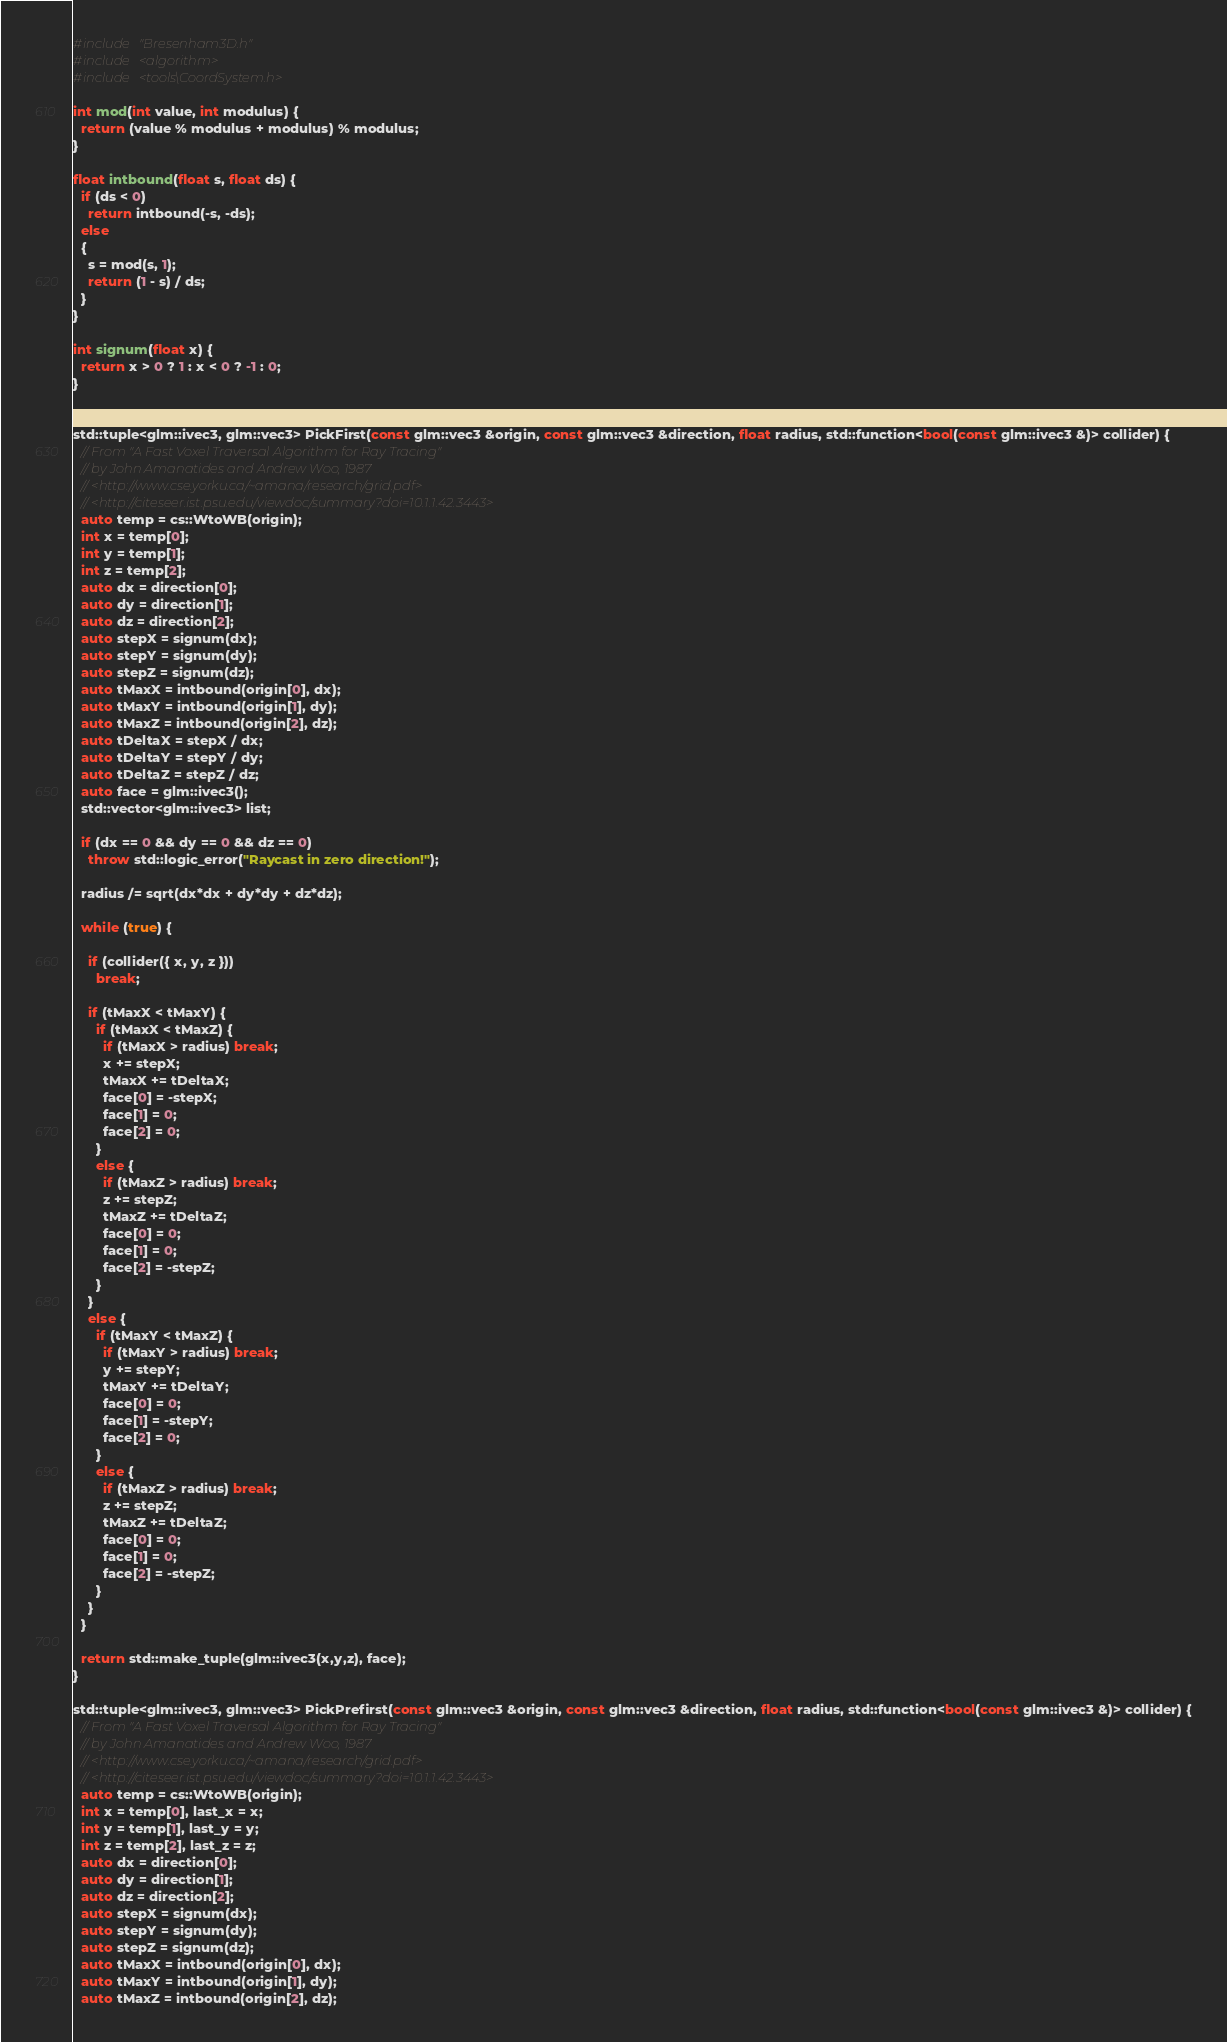<code> <loc_0><loc_0><loc_500><loc_500><_C++_>#include "Bresenham3D.h"
#include <algorithm>
#include <tools\CoordSystem.h>

int mod(int value, int modulus) {
  return (value % modulus + modulus) % modulus;
}

float intbound(float s, float ds) {
  if (ds < 0)
    return intbound(-s, -ds);
  else 
  {
    s = mod(s, 1);
    return (1 - s) / ds;
  }
}

int signum(float x) {
  return x > 0 ? 1 : x < 0 ? -1 : 0;
}


std::tuple<glm::ivec3, glm::vec3> PickFirst(const glm::vec3 &origin, const glm::vec3 &direction, float radius, std::function<bool(const glm::ivec3 &)> collider) {
  // From "A Fast Voxel Traversal Algorithm for Ray Tracing"
  // by John Amanatides and Andrew Woo, 1987
  // <http://www.cse.yorku.ca/~amana/research/grid.pdf>
  // <http://citeseer.ist.psu.edu/viewdoc/summary?doi=10.1.1.42.3443>
  auto temp = cs::WtoWB(origin);
  int x = temp[0];
  int y = temp[1];
  int z = temp[2];
  auto dx = direction[0];
  auto dy = direction[1];
  auto dz = direction[2];
  auto stepX = signum(dx);
  auto stepY = signum(dy);
  auto stepZ = signum(dz);
  auto tMaxX = intbound(origin[0], dx);
  auto tMaxY = intbound(origin[1], dy);
  auto tMaxZ = intbound(origin[2], dz);
  auto tDeltaX = stepX / dx;
  auto tDeltaY = stepY / dy;
  auto tDeltaZ = stepZ / dz;
  auto face = glm::ivec3();
  std::vector<glm::ivec3> list;

  if (dx == 0 && dy == 0 && dz == 0)
    throw std::logic_error("Raycast in zero direction!");

  radius /= sqrt(dx*dx + dy*dy + dz*dz);

  while (true) {

    if (collider({ x, y, z }))
      break;

    if (tMaxX < tMaxY) {
      if (tMaxX < tMaxZ) {
        if (tMaxX > radius) break;
        x += stepX;
        tMaxX += tDeltaX;
        face[0] = -stepX;
        face[1] = 0;
        face[2] = 0;
      }
      else {
        if (tMaxZ > radius) break;
        z += stepZ;
        tMaxZ += tDeltaZ;
        face[0] = 0;
        face[1] = 0;
        face[2] = -stepZ;
      }
    }
    else {
      if (tMaxY < tMaxZ) {
        if (tMaxY > radius) break;
        y += stepY;
        tMaxY += tDeltaY;
        face[0] = 0;
        face[1] = -stepY;
        face[2] = 0;
      }
      else {
        if (tMaxZ > radius) break;
        z += stepZ;
        tMaxZ += tDeltaZ;
        face[0] = 0;
        face[1] = 0;
        face[2] = -stepZ;
      }
    }
  }

  return std::make_tuple(glm::ivec3(x,y,z), face);
}

std::tuple<glm::ivec3, glm::vec3> PickPrefirst(const glm::vec3 &origin, const glm::vec3 &direction, float radius, std::function<bool(const glm::ivec3 &)> collider) {
  // From "A Fast Voxel Traversal Algorithm for Ray Tracing"
  // by John Amanatides and Andrew Woo, 1987
  // <http://www.cse.yorku.ca/~amana/research/grid.pdf>
  // <http://citeseer.ist.psu.edu/viewdoc/summary?doi=10.1.1.42.3443>
  auto temp = cs::WtoWB(origin);
  int x = temp[0], last_x = x;
  int y = temp[1], last_y = y;
  int z = temp[2], last_z = z;
  auto dx = direction[0];
  auto dy = direction[1];
  auto dz = direction[2];
  auto stepX = signum(dx);
  auto stepY = signum(dy);
  auto stepZ = signum(dz);
  auto tMaxX = intbound(origin[0], dx);
  auto tMaxY = intbound(origin[1], dy);
  auto tMaxZ = intbound(origin[2], dz);</code> 